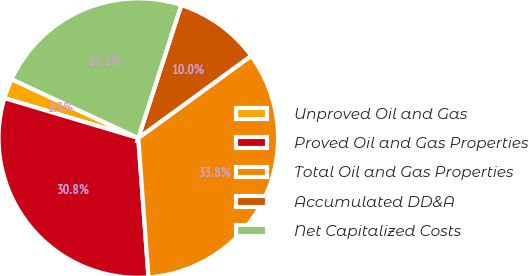Convert chart to OTSL. <chart><loc_0><loc_0><loc_500><loc_500><pie_chart><fcel>Unproved Oil and Gas<fcel>Proved Oil and Gas Properties<fcel>Total Oil and Gas Properties<fcel>Accumulated DD&A<fcel>Net Capitalized Costs<nl><fcel>2.3%<fcel>30.78%<fcel>33.85%<fcel>10.01%<fcel>23.06%<nl></chart> 